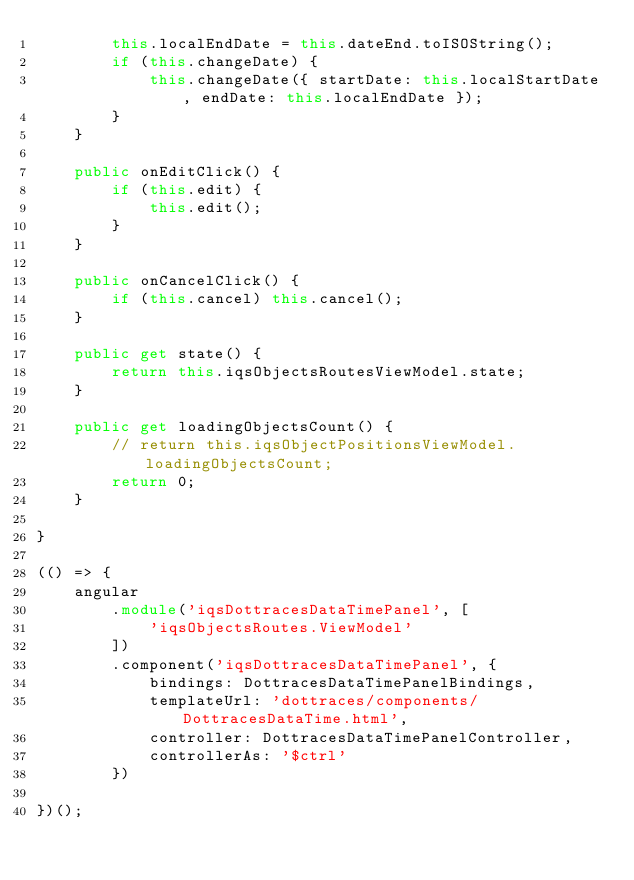<code> <loc_0><loc_0><loc_500><loc_500><_TypeScript_>        this.localEndDate = this.dateEnd.toISOString();
        if (this.changeDate) {
            this.changeDate({ startDate: this.localStartDate, endDate: this.localEndDate });
        }
    }

    public onEditClick() {
        if (this.edit) {
            this.edit();
        }
    }

    public onCancelClick() {
        if (this.cancel) this.cancel();
    }

    public get state() {
        return this.iqsObjectsRoutesViewModel.state;
    }

    public get loadingObjectsCount() {
        // return this.iqsObjectPositionsViewModel.loadingObjectsCount;
        return 0;
    }

}

(() => {
    angular
        .module('iqsDottracesDataTimePanel', [
            'iqsObjectsRoutes.ViewModel'
        ])
        .component('iqsDottracesDataTimePanel', {
            bindings: DottracesDataTimePanelBindings,
            templateUrl: 'dottraces/components/DottracesDataTime.html',
            controller: DottracesDataTimePanelController,
            controllerAs: '$ctrl'
        })

})();
</code> 